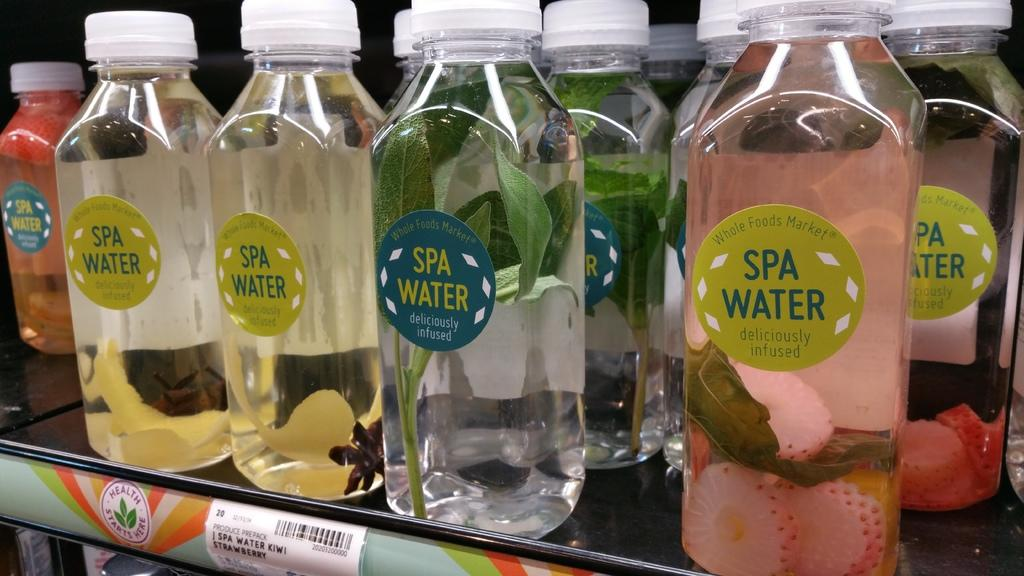<image>
Summarize the visual content of the image. Various flavors of Spa Water are displayed on a shop shelf. 